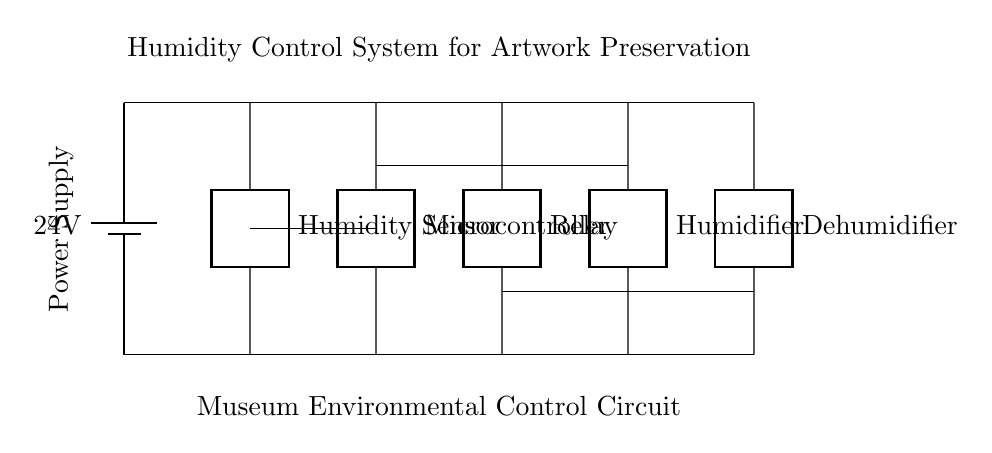What is the voltage of this circuit? The circuit contains a battery labeled with a voltage of 24 volts. This is the potential difference supplied by the power supply in the circuit.
Answer: 24 volts What components are present in the circuit? The circuit includes five main components: a humidity sensor, a microcontroller, a relay, a humidifier, and a dehumidifier, each depicted with a label in the diagram.
Answer: Humidity sensor, microcontroller, relay, humidifier, dehumidifier What role does the microcontroller play in this circuit? The microcontroller acts as the control unit, processing data from the humidity sensor and managing the relay to activate or deactivate the humidifier and dehumidifier based on humidity levels.
Answer: Control unit How are the humidifier and dehumidifier connected in this circuit? The humidifier and dehumidifier are connected through the relay, which is controlled by the microcontroller. This allows the microcontroller to switch between activating the humidifier or the dehumidifier depending on the current humidity status.
Answer: Through the relay What is the function of the humidity sensor in this circuit? The humidity sensor detects the moisture level in the environment and sends the data to the microcontroller, enabling it to make decisions about whether to activate the humidifier or the dehumidifier for artwork preservation.
Answer: Moisture detection What is the purpose of the relay in this circuit? The relay serves as a switch that allows the microcontroller to control the power supply to the humidifier and dehumidifier based on the commands it receives. This helps in managing the humidity levels effectively.
Answer: Switch for control 